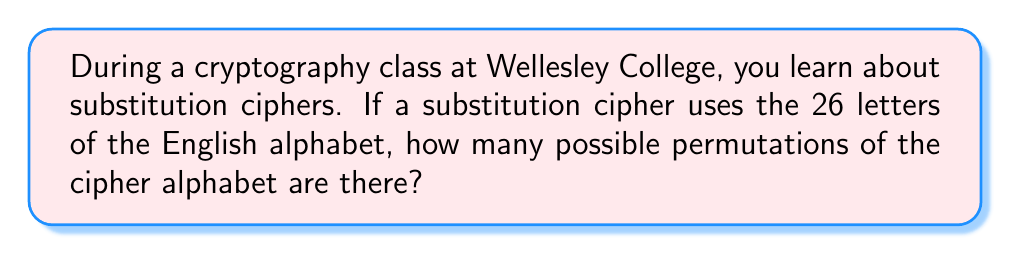Solve this math problem. To solve this problem, let's follow these steps:

1) In a substitution cipher, each letter of the plaintext alphabet is replaced by a different letter of the cipher alphabet. This means we need to arrange all 26 letters of the alphabet in a new order.

2) This is a permutation problem. We are arranging 26 distinct objects (letters) in a specific order.

3) The number of ways to arrange n distinct objects is given by the factorial of n, denoted as n!

4) In this case, n = 26 (for the 26 letters of the English alphabet)

5) Therefore, the number of possible permutations is:

   $$26! = 26 \times 25 \times 24 \times ... \times 3 \times 2 \times 1$$

6) This is a very large number. We can calculate it:

   $$26! = 403,291,461,126,605,635,584,000,000$$

This means there are over 403 septillion possible permutations for a substitution cipher using the English alphabet.
Answer: $26!$ or $403,291,461,126,605,635,584,000,000$ 